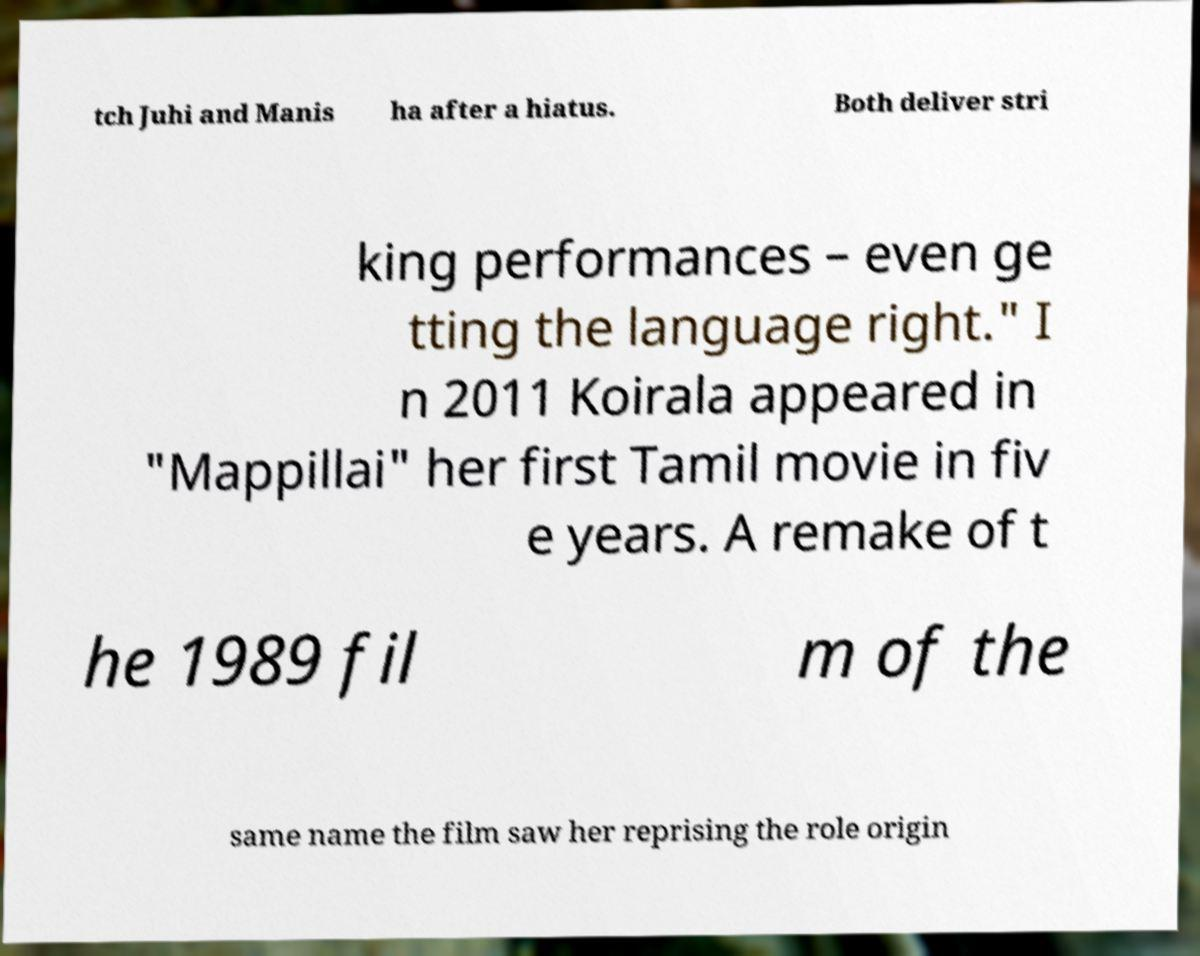Could you assist in decoding the text presented in this image and type it out clearly? tch Juhi and Manis ha after a hiatus. Both deliver stri king performances – even ge tting the language right." I n 2011 Koirala appeared in "Mappillai" her first Tamil movie in fiv e years. A remake of t he 1989 fil m of the same name the film saw her reprising the role origin 